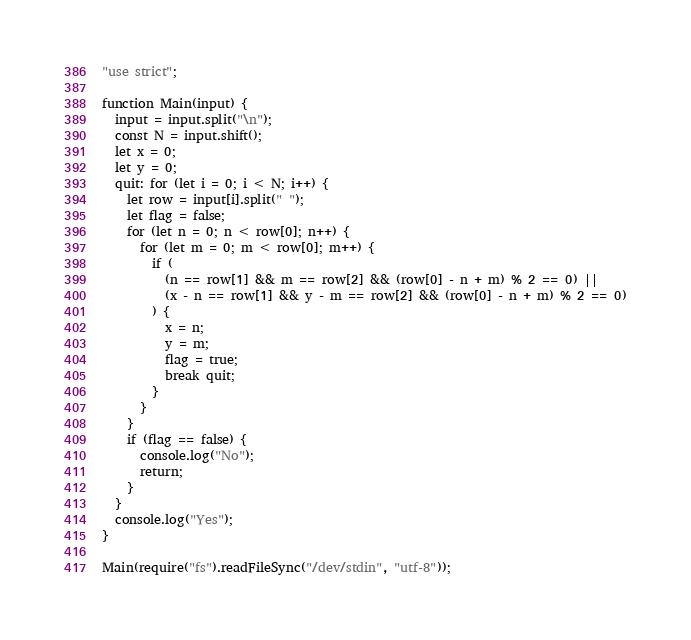Convert code to text. <code><loc_0><loc_0><loc_500><loc_500><_JavaScript_>"use strict";

function Main(input) {
  input = input.split("\n");
  const N = input.shift();
  let x = 0;
  let y = 0;
  quit: for (let i = 0; i < N; i++) {
    let row = input[i].split(" ");
    let flag = false;
    for (let n = 0; n < row[0]; n++) {
      for (let m = 0; m < row[0]; m++) {
        if (
          (n == row[1] && m == row[2] && (row[0] - n + m) % 2 == 0) ||
          (x - n == row[1] && y - m == row[2] && (row[0] - n + m) % 2 == 0)
        ) {
          x = n;
          y = m;
          flag = true;
          break quit;
        }
      }
    }
    if (flag == false) {
      console.log("No");
      return;
    }
  }
  console.log("Yes");
}

Main(require("fs").readFileSync("/dev/stdin", "utf-8"));
</code> 